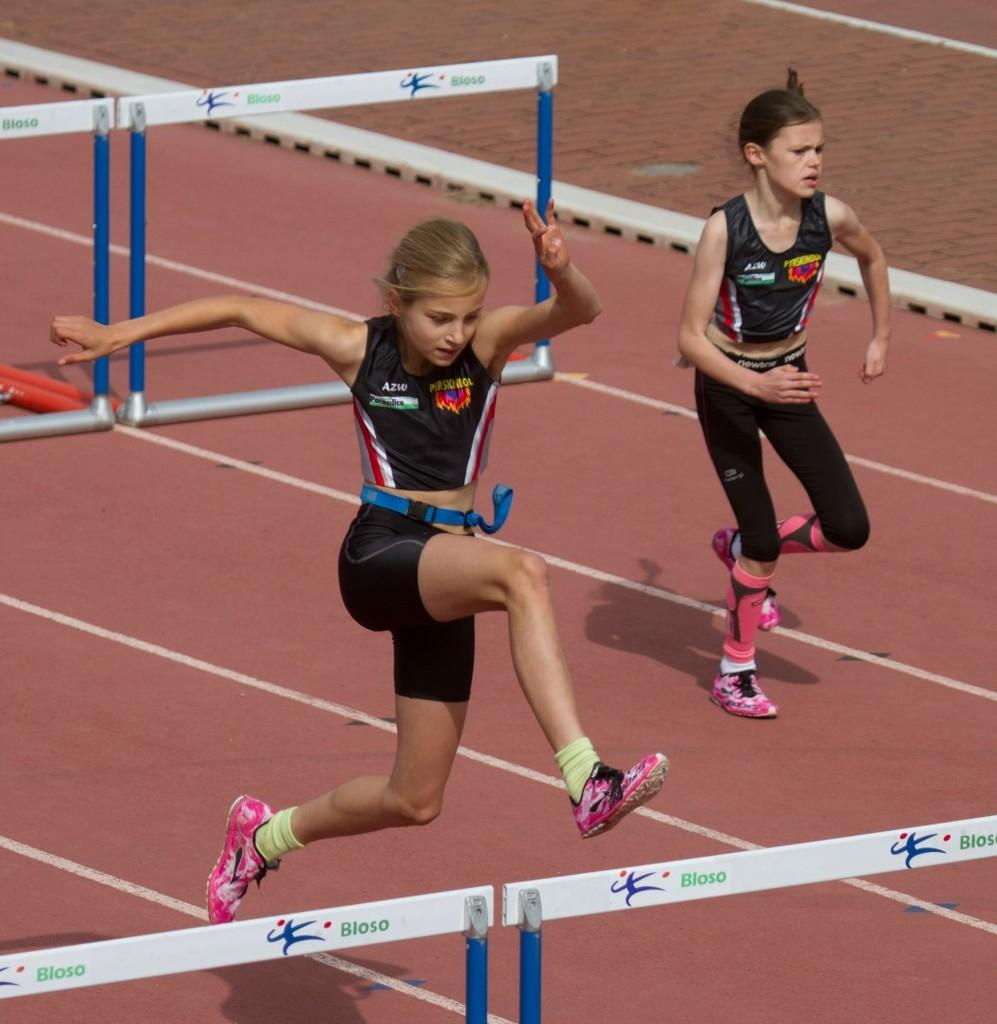What is the main subject of the image? There is a girl in the image. What is the girl doing in the image? The girl is running. What is the girl wearing in the image? The girl is wearing a black dress. Are there any other people in the image? Yes, there is another girl in the image. What is the other girl doing in the image? The other girl is also running. What type of club can be seen in the girl's hand in the image? There is no club visible in the girl's hand in the image. Why is the girl crying while running in the image? The girl is not crying in the image; she is running with a neutral expression. 